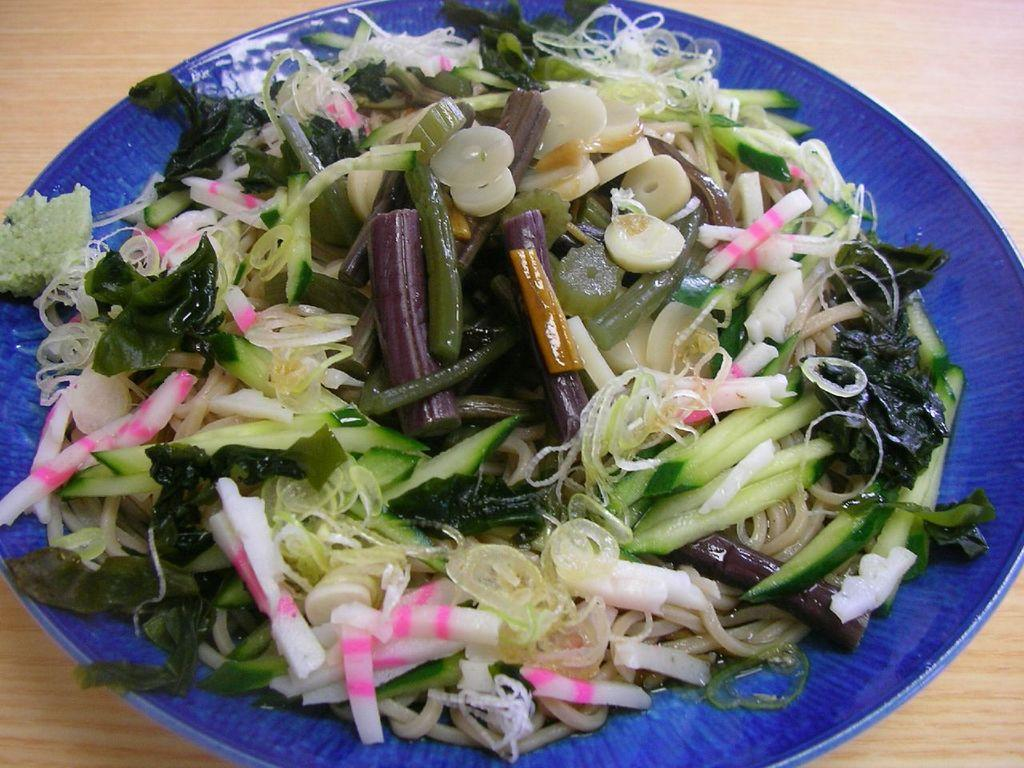What is on the plate in the image? There are food items on the plate in the image. Where is the plate located? The plate is on a platform. What type of receipt can be seen next to the food items on the plate? There is no receipt present next to the food items on the plate in the image. 